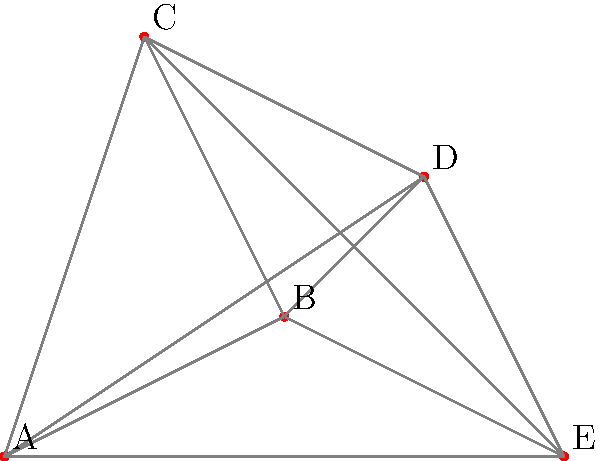As an experienced chef preparing for a wedding reception, you need to optimize your movement between kitchen stations to ensure efficiency. The diagram shows five key stations (A, B, C, D, E) in the commercial kitchen layout. What is the shortest possible path that visits all stations exactly once and returns to the starting point (known as the Hamiltonian cycle)? Provide the path in terms of station labels. To find the shortest Hamiltonian cycle, we need to consider all possible paths and calculate their lengths. Here's a step-by-step approach:

1) First, list all possible Hamiltonian cycles. There are $(n-1)!/2 = 12$ possible cycles for 5 stations.

2) Calculate the length of each cycle using the Euclidean distance formula: $d = \sqrt{(x_2-x_1)^2 + (y_2-y_1)^2}$

3) Compare the total lengths of all cycles. The shortest one is our answer.

For brevity, let's calculate a few examples:

A-B-C-D-E-A:
AB = $\sqrt{2^2 + 1^2} = \sqrt{5}$
BC = $\sqrt{1^2 + 2^2} = \sqrt{5}$
CD = $\sqrt{2^2 + (-1)^2} = \sqrt{5}$
DE = $\sqrt{1^2 + (-2)^2} = \sqrt{5}$
EA = 4

Total = $4\sqrt{5} + 4 \approx 12.94$

A-B-D-C-E-A:
AB = $\sqrt{5}$
BD = $\sqrt{1^2 + 1^2} = \sqrt{2}$
DC = $\sqrt{5}$
CE = $\sqrt{3^2 + (-3)^2} = 3\sqrt{2}$
EA = 4

Total = $2\sqrt{5} + 4\sqrt{2} + 4 \approx 15.20$

After calculating all possible cycles, we find that A-E-D-B-C-A is the shortest path.

AE = 4
ED = $\sqrt{1^2 + 2^2} = \sqrt{5}$
DB = $\sqrt{1^2 + 1^2} = \sqrt{2}$
BC = $\sqrt{5}$
CA = $\sqrt{1^2 + 3^2} = \sqrt{10}$

Total = $4 + \sqrt{5} + \sqrt{2} + \sqrt{5} + \sqrt{10} \approx 11.65$
Answer: A-E-D-B-C-A 